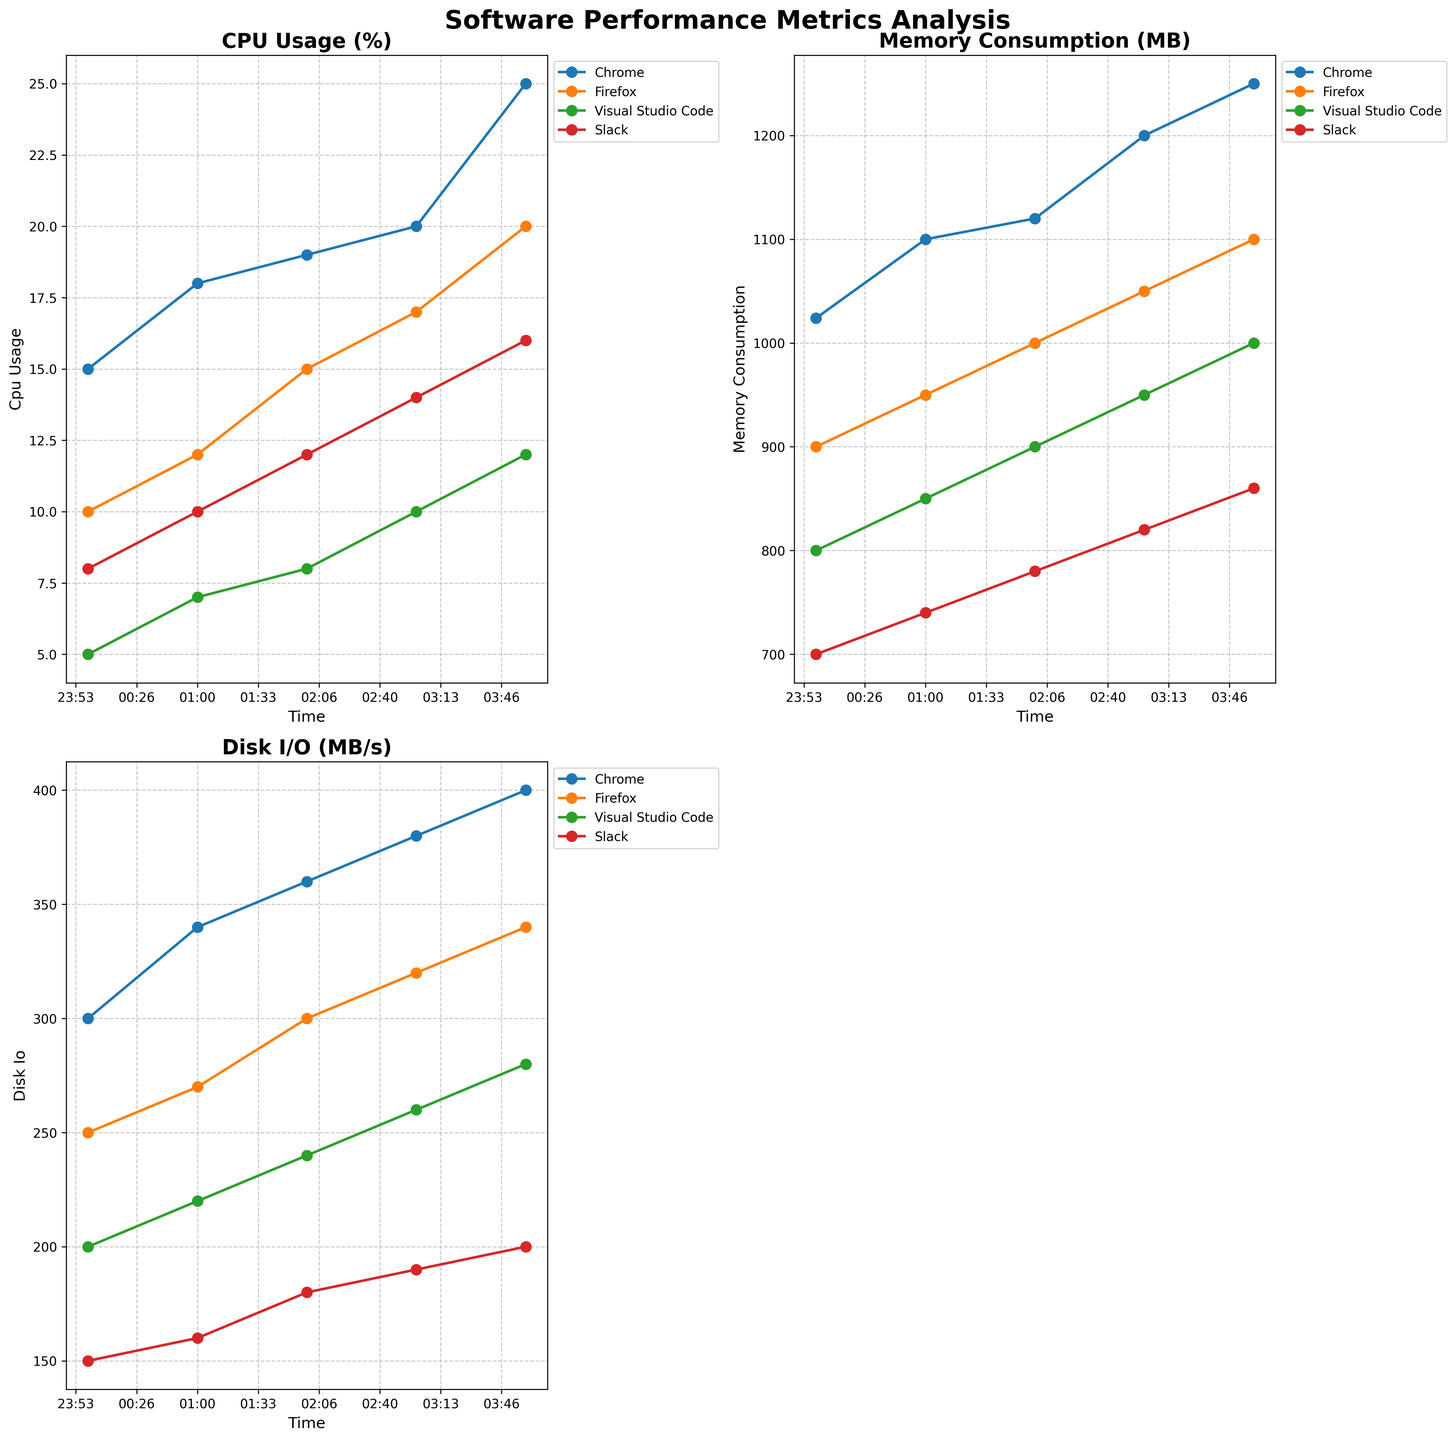What is the title of the chart on the top left subplot? The top left subplot's title is visible at the top of the plot.
Answer: CPU Usage (%) Which application had the highest CPU usage at 4 AM? Identify the lines corresponding to 4 AM on the x-axis and look for the tallest line among the applications.
Answer: Chrome Which application shows the most consistent memory consumption over time? Check the memory consumption plot and look at the trend lines for each application to see which one has the least variation.
Answer: Slack What is the trend of disk I/O for Visual Studio Code? Look at the disk I/O subplot and observe the line corresponding to Visual Studio Code to see if it's increasing, decreasing, or steady.
Answer: Increasing What are the units for the y-axis in the bottom left subplot? The title and axis labels usually provide the units of measurement.
Answer: MB/s How does the CPU usage of Chrome change from 1 AM to 4 AM? Examine the time points for 1 AM and 4 AM on the x-axis in the CPU usage plot and compare the values.
Answer: Increases from 18% to 25% Which two applications have the closest disk I/O values at 2 AM? Find the disk I/O values at 2 AM for all applications and compare them to find the closest pair.
Answer: Firefox and Chrome How much did the memory consumption for Slack increase from 2 AM to 4 AM? Subtract the memory consumption value at 2 AM from the value at 4 AM for Slack.
Answer: 80 MB Which metric has the most substantial overall growth for any application? Compare the trends across all metrics in their respective subplots to see which metric shows the largest increase.
Answer: Disk I/O for Chrome At what time is the CPU usage for Firefox equal to its memory consumption? Look for an intersection point where the CPU usage value matches the memory consumption value for Firefox.
Answer: Never 